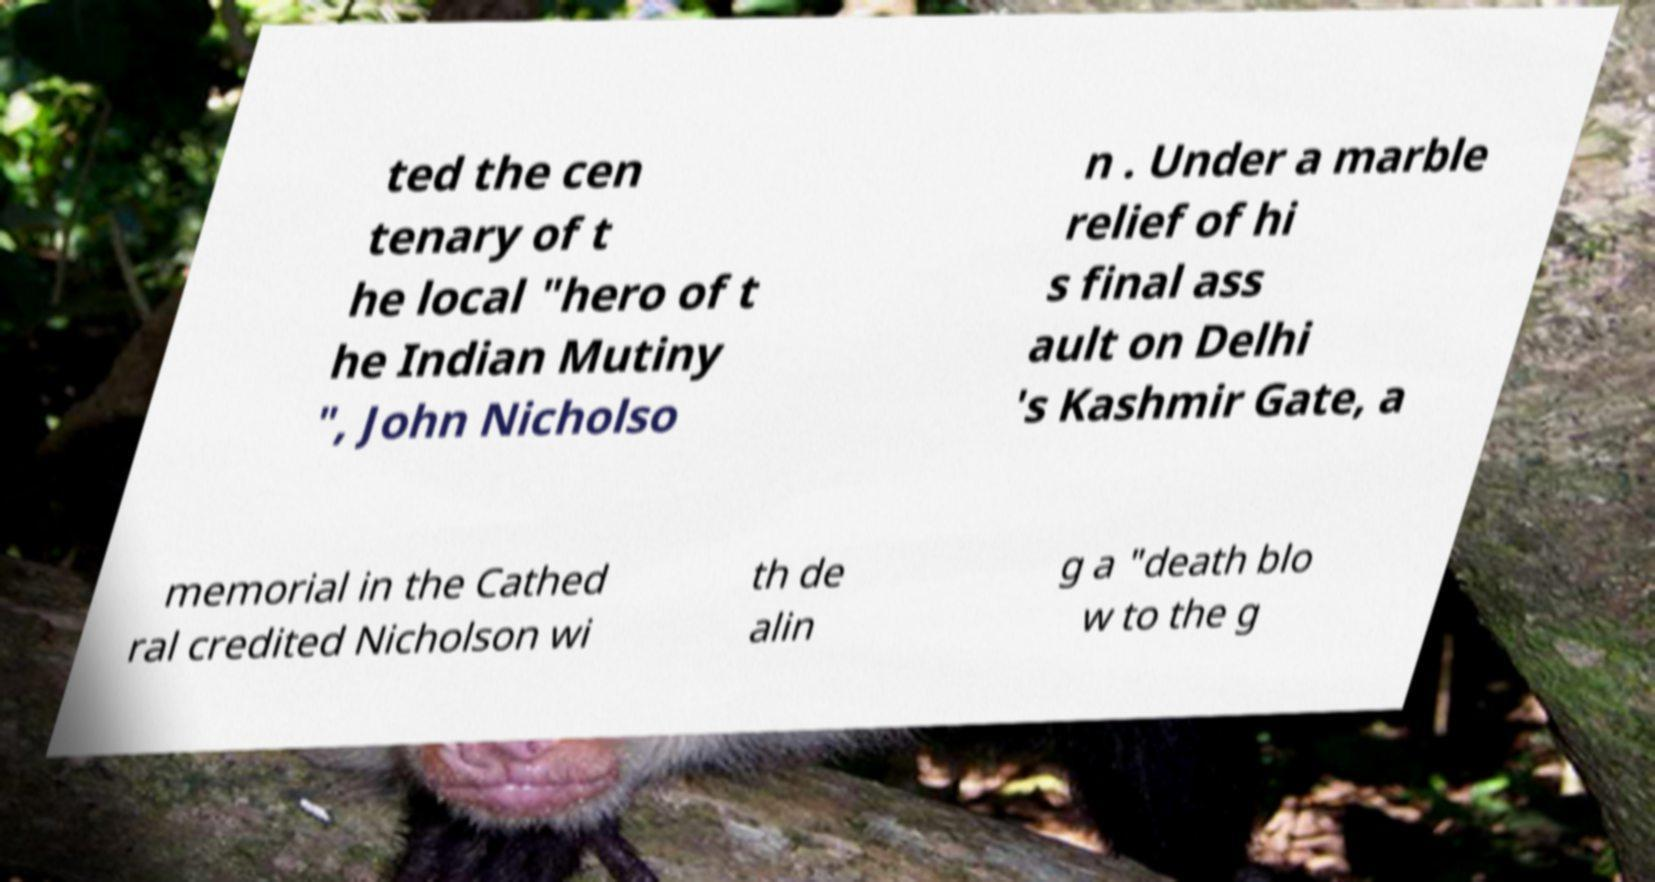Please read and relay the text visible in this image. What does it say? ted the cen tenary of t he local "hero of t he Indian Mutiny ", John Nicholso n . Under a marble relief of hi s final ass ault on Delhi 's Kashmir Gate, a memorial in the Cathed ral credited Nicholson wi th de alin g a "death blo w to the g 